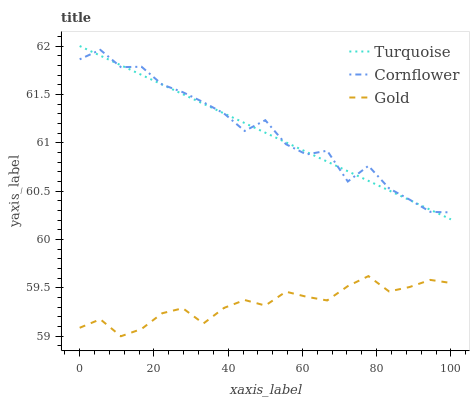Does Turquoise have the minimum area under the curve?
Answer yes or no. No. Does Turquoise have the maximum area under the curve?
Answer yes or no. No. Is Gold the smoothest?
Answer yes or no. No. Is Gold the roughest?
Answer yes or no. No. Does Turquoise have the lowest value?
Answer yes or no. No. Does Gold have the highest value?
Answer yes or no. No. Is Gold less than Turquoise?
Answer yes or no. Yes. Is Cornflower greater than Gold?
Answer yes or no. Yes. Does Gold intersect Turquoise?
Answer yes or no. No. 